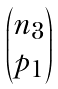<formula> <loc_0><loc_0><loc_500><loc_500>\begin{pmatrix} n _ { 3 } \\ p _ { 1 } \end{pmatrix}</formula> 